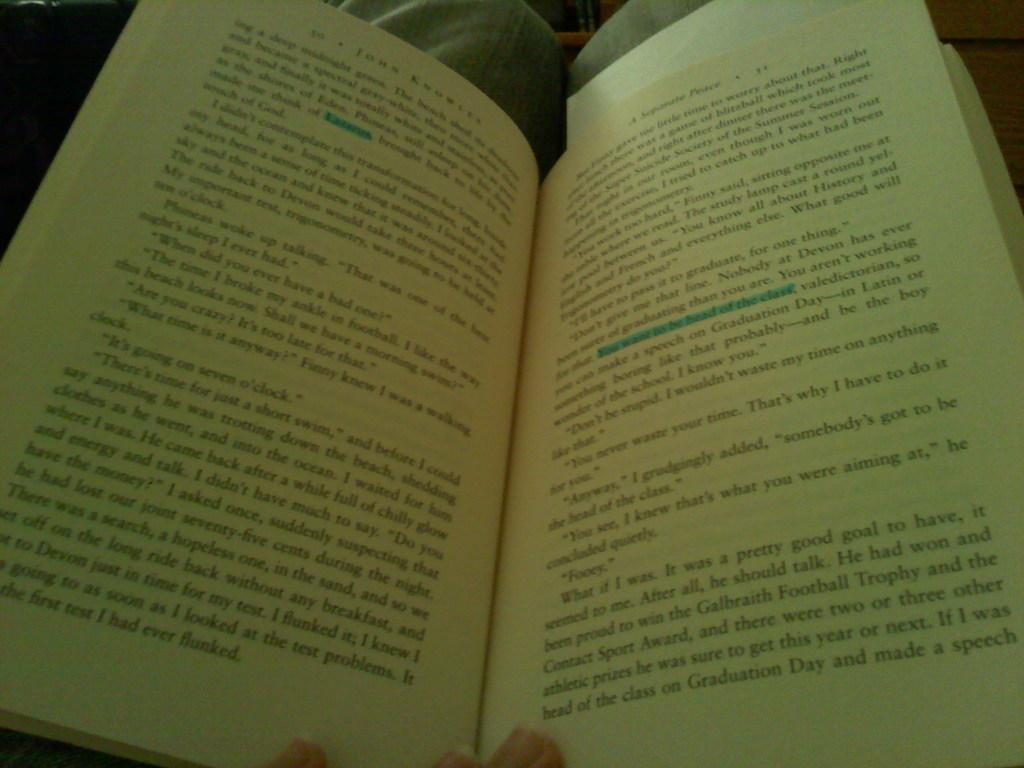Provide a one-sentence caption for the provided image. A person is reading page 31 of a book with a blue highlighter drawn in it. 